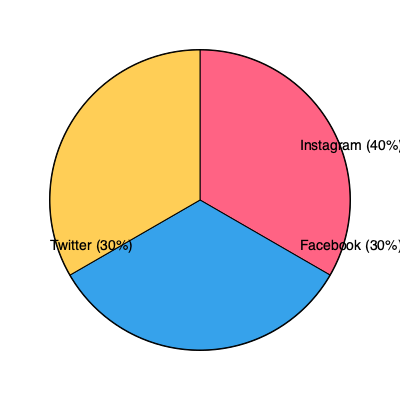Based on the pie chart showing social media platform user demographics, which platform would be most effective for targeting the largest audience in a marketing campaign, and what percentage of users does it represent? To determine the most effective platform for targeting the largest audience, we need to analyze the percentages given in the pie chart:

1. Instagram: 40% of users
2. Facebook: 30% of users
3. Twitter: 30% of users

Step 1: Compare the percentages
Instagram has the highest percentage at 40%, while both Facebook and Twitter have 30% each.

Step 2: Identify the largest audience
The platform with the largest audience is Instagram, as it has the highest percentage of users (40%).

Step 3: Calculate the difference
Instagram has 10% more users than either Facebook or Twitter (40% - 30% = 10%).

Therefore, Instagram would be the most effective platform for targeting the largest audience in a marketing campaign, representing 40% of the users in the given demographic.
Answer: Instagram, 40% 